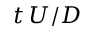Convert formula to latex. <formula><loc_0><loc_0><loc_500><loc_500>t \, U / D</formula> 